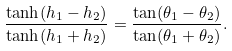<formula> <loc_0><loc_0><loc_500><loc_500>\frac { \tanh ( h _ { 1 } - h _ { 2 } ) } { \tanh ( h _ { 1 } + h _ { 2 } ) } = \frac { \tan ( \theta _ { 1 } - \theta _ { 2 } ) } { \tan ( \theta _ { 1 } + \theta _ { 2 } ) } .</formula> 